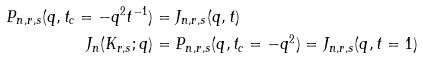Convert formula to latex. <formula><loc_0><loc_0><loc_500><loc_500>P _ { n , r , s } ( q , t _ { c } = - q ^ { 2 } t ^ { - 1 } ) & = J _ { n , r , s } ( q , t ) \\ J _ { n } ( K _ { r , s } ; q ) & = P _ { n , r , s } ( q , t _ { c } = - q ^ { 2 } ) = J _ { n , r , s } ( q , t = 1 )</formula> 